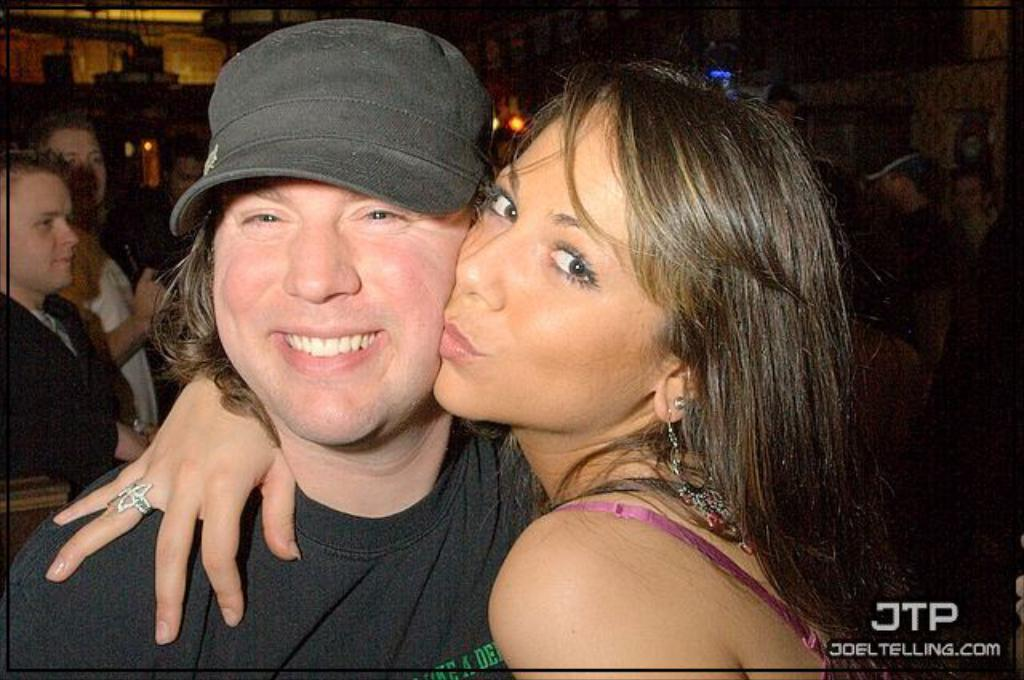Who is the main subject in the foreground of the image? There is a woman in the foreground of the image. What is the woman doing in the image? The woman is kissing a man's cheek. What can be seen on the man's head? The man is wearing a cap on his head. What can be observed in the background of the image? In the background, there are people visible. How would you describe the lighting in the background of the image? The background appears to be dark. What type of worm can be seen crawling on the man's cap in the image? There is no worm present on the man's cap in the image. What nut is being used to secure the system in the image? There is no system or nut present in the image. 